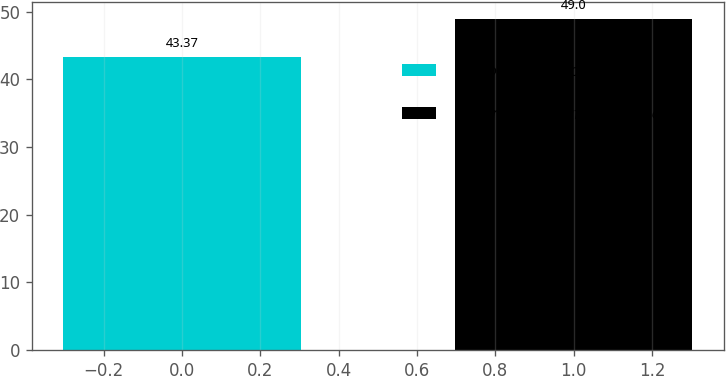Convert chart. <chart><loc_0><loc_0><loc_500><loc_500><bar_chart><fcel>Alberta Canada (2)<fcel>Florence South Carolina<nl><fcel>43.37<fcel>49<nl></chart> 